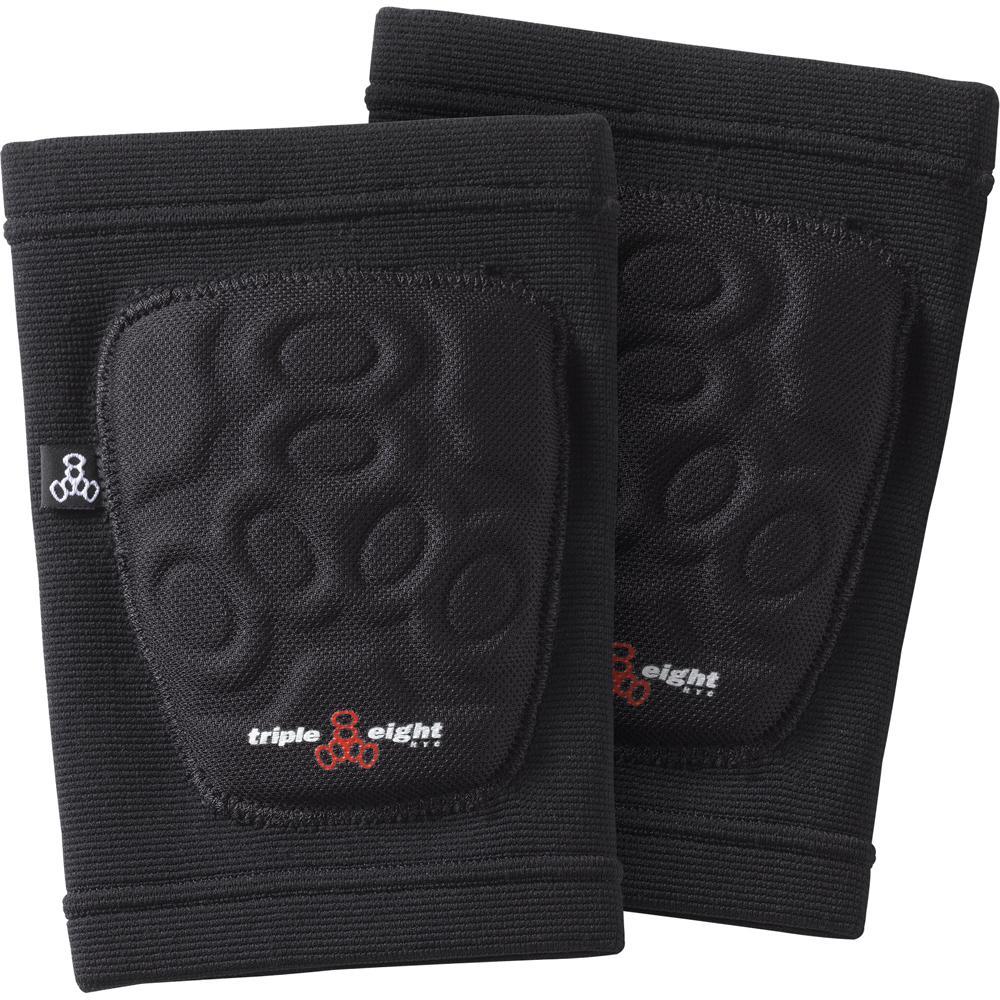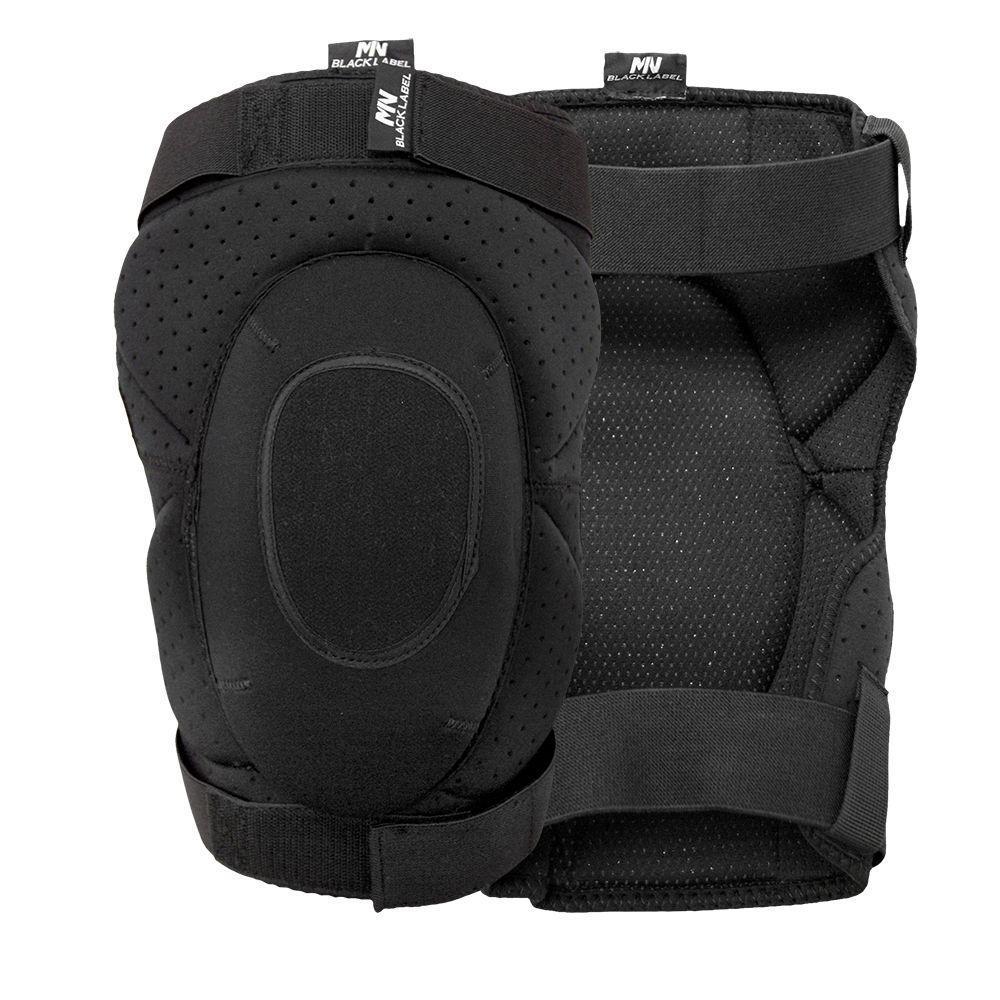The first image is the image on the left, the second image is the image on the right. Given the left and right images, does the statement "Right image shows a pair of black kneepads turned rightward." hold true? Answer yes or no. No. 